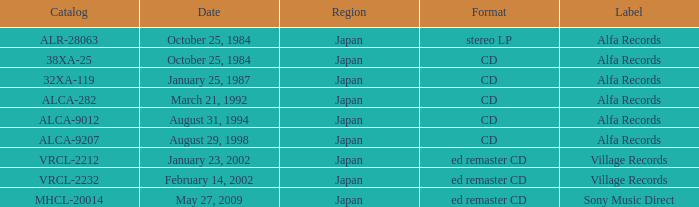What Label released on October 25, 1984, in the format of Stereo LP? Alfa Records. 